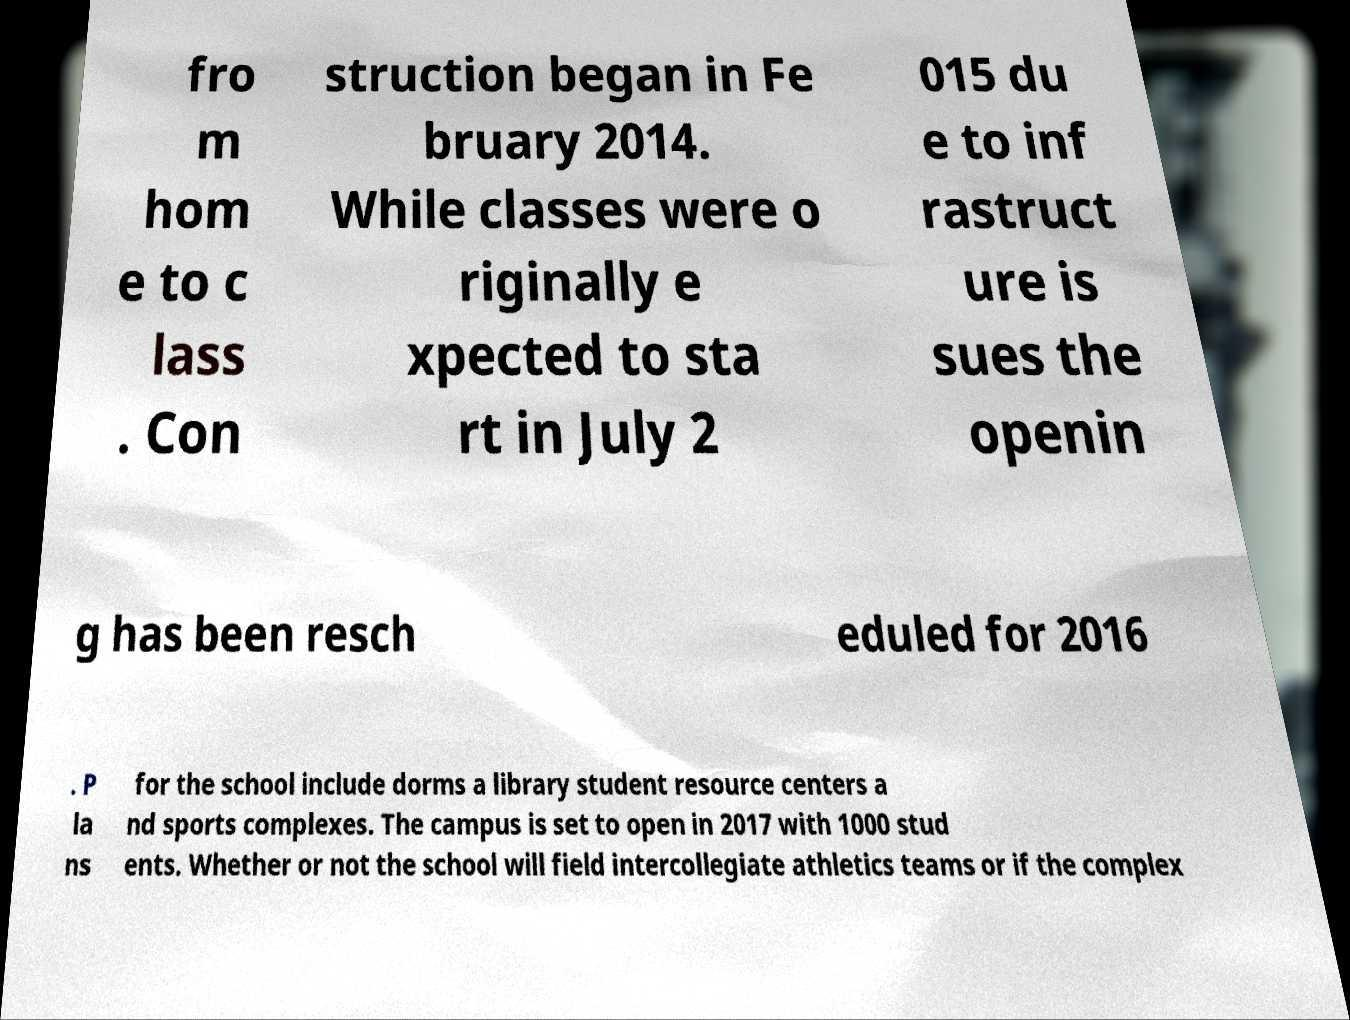Please identify and transcribe the text found in this image. fro m hom e to c lass . Con struction began in Fe bruary 2014. While classes were o riginally e xpected to sta rt in July 2 015 du e to inf rastruct ure is sues the openin g has been resch eduled for 2016 . P la ns for the school include dorms a library student resource centers a nd sports complexes. The campus is set to open in 2017 with 1000 stud ents. Whether or not the school will field intercollegiate athletics teams or if the complex 